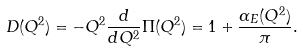Convert formula to latex. <formula><loc_0><loc_0><loc_500><loc_500>D ( Q ^ { 2 } ) = - Q ^ { 2 } \frac { d } { d Q ^ { 2 } } \Pi ( Q ^ { 2 } ) = 1 + \frac { \alpha _ { E } ( Q ^ { 2 } ) } \pi .</formula> 